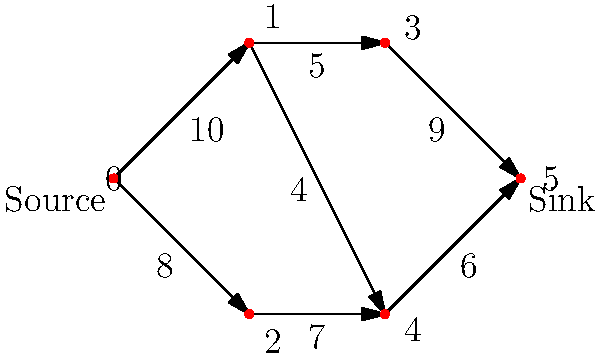In the context of government communication channels, the diagram represents a network of information flow between different departments. Each edge represents a communication channel with a maximum capacity (in units of information per hour). What is the maximum flow of information that can be transmitted from the source (node 0) to the sink (node 5) per hour? To solve this maximum flow problem, we'll use the Ford-Fulkerson algorithm:

1. Initialize flow to 0.
2. Find an augmenting path from source to sink:
   a) Path: 0 -> 1 -> 3 -> 5, Flow: min(10, 5, 9) = 5
   b) Update residual graph and add 5 to flow. Flow = 5
3. Find another augmenting path:
   a) Path: 0 -> 2 -> 4 -> 5, Flow: min(8, 7, 6) = 6
   b) Update residual graph and add 6 to flow. Flow = 11
4. Find another augmenting path:
   a) Path: 0 -> 1 -> 4 -> 5, Flow: min(5, 4, 0) = 0
   b) No more augmenting paths with positive flow.

The maximum flow is the sum of all augmenting path flows: 5 + 6 = 11.

This result indicates that the government communication network can transmit a maximum of 11 units of information per hour from the source department to the sink department, utilizing various inter-departmental channels efficiently.
Answer: 11 units per hour 